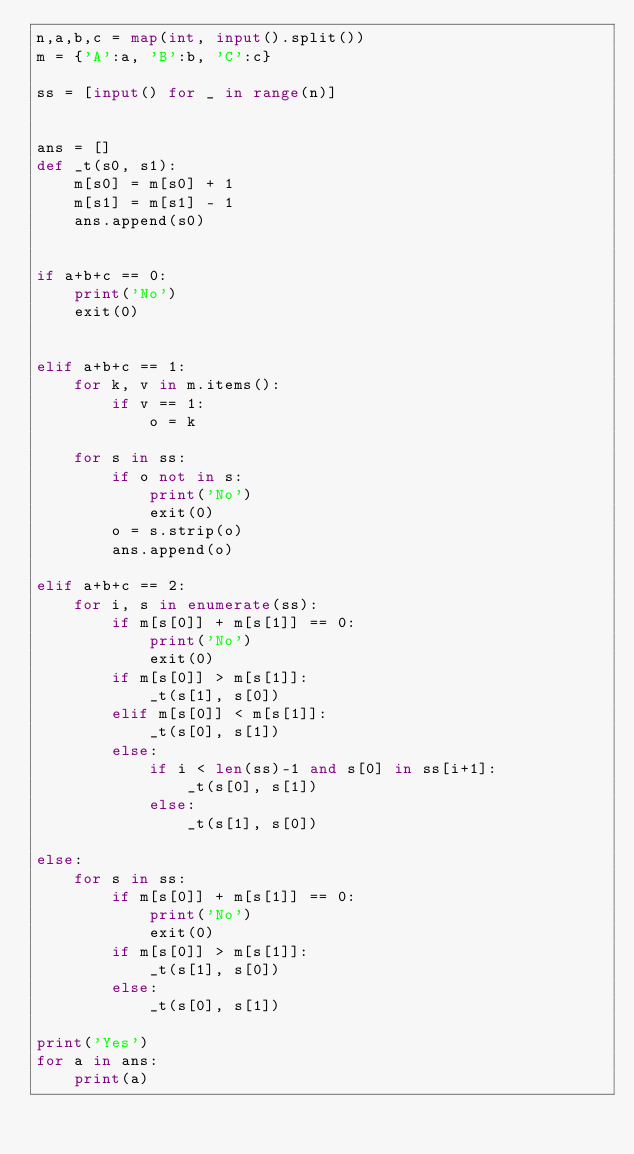<code> <loc_0><loc_0><loc_500><loc_500><_Python_>n,a,b,c = map(int, input().split())
m = {'A':a, 'B':b, 'C':c}

ss = [input() for _ in range(n)]


ans = []
def _t(s0, s1):
    m[s0] = m[s0] + 1
    m[s1] = m[s1] - 1
    ans.append(s0)


if a+b+c == 0:
    print('No')
    exit(0)


elif a+b+c == 1:
    for k, v in m.items():
        if v == 1:
            o = k

    for s in ss:
        if o not in s:
            print('No')
            exit(0)
        o = s.strip(o)
        ans.append(o)

elif a+b+c == 2:
    for i, s in enumerate(ss):
        if m[s[0]] + m[s[1]] == 0:
            print('No')
            exit(0)
        if m[s[0]] > m[s[1]]:
            _t(s[1], s[0])
        elif m[s[0]] < m[s[1]]:
            _t(s[0], s[1])
        else:
            if i < len(ss)-1 and s[0] in ss[i+1]:
                _t(s[0], s[1])
            else:
                _t(s[1], s[0])

else:
    for s in ss:
        if m[s[0]] + m[s[1]] == 0:
            print('No')
            exit(0)
        if m[s[0]] > m[s[1]]:
            _t(s[1], s[0])
        else:
            _t(s[0], s[1])

print('Yes')
for a in ans:
    print(a)
</code> 